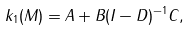<formula> <loc_0><loc_0><loc_500><loc_500>k _ { 1 } ( M ) = A + B ( I - D ) ^ { - 1 } C ,</formula> 